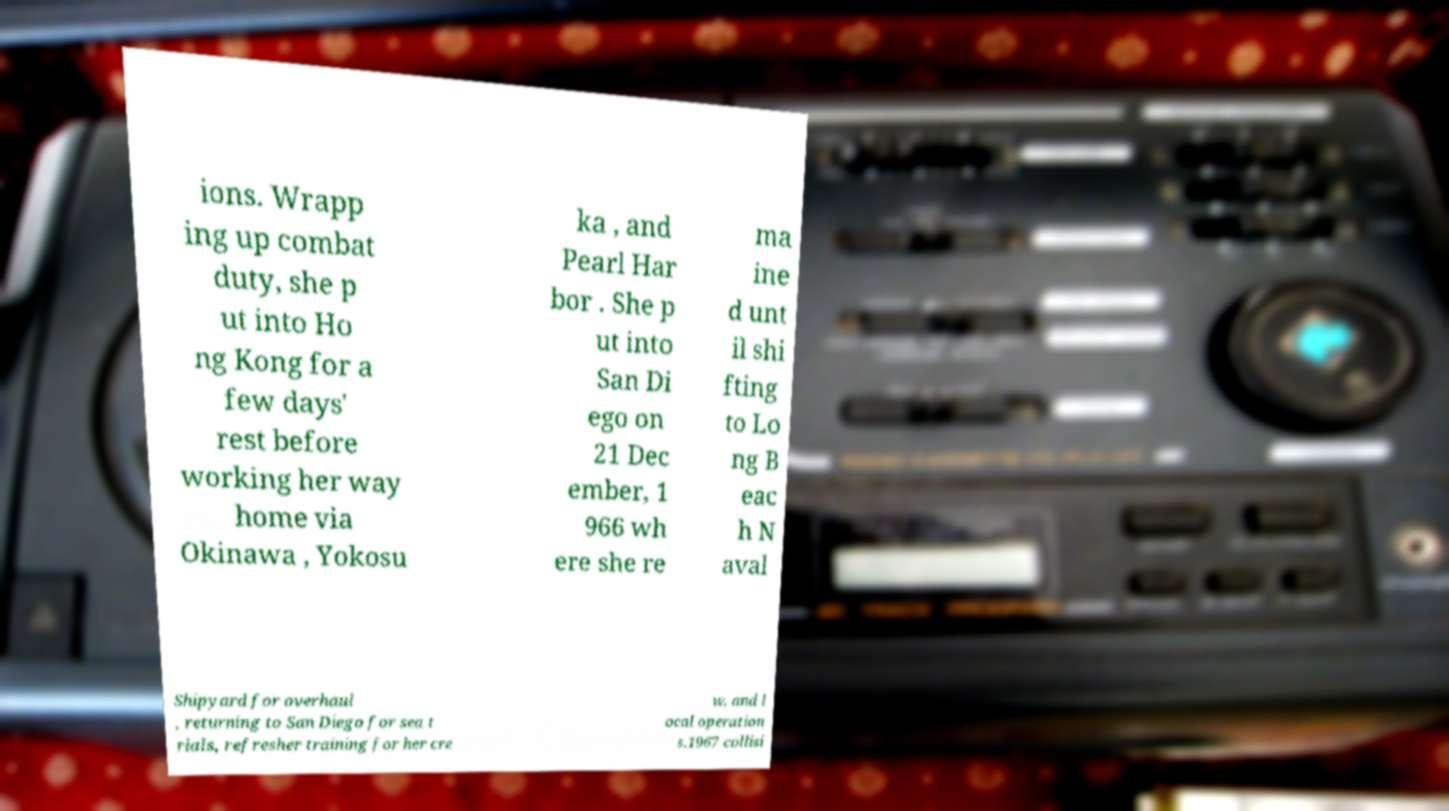There's text embedded in this image that I need extracted. Can you transcribe it verbatim? ions. Wrapp ing up combat duty, she p ut into Ho ng Kong for a few days' rest before working her way home via Okinawa , Yokosu ka , and Pearl Har bor . She p ut into San Di ego on 21 Dec ember, 1 966 wh ere she re ma ine d unt il shi fting to Lo ng B eac h N aval Shipyard for overhaul , returning to San Diego for sea t rials, refresher training for her cre w, and l ocal operation s.1967 collisi 